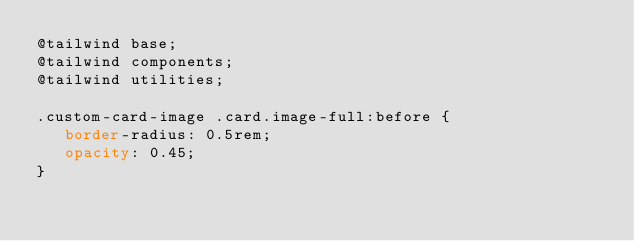Convert code to text. <code><loc_0><loc_0><loc_500><loc_500><_CSS_>@tailwind base;
@tailwind components;
@tailwind utilities;

.custom-card-image .card.image-full:before {
   border-radius: 0.5rem;
   opacity: 0.45;
}
</code> 